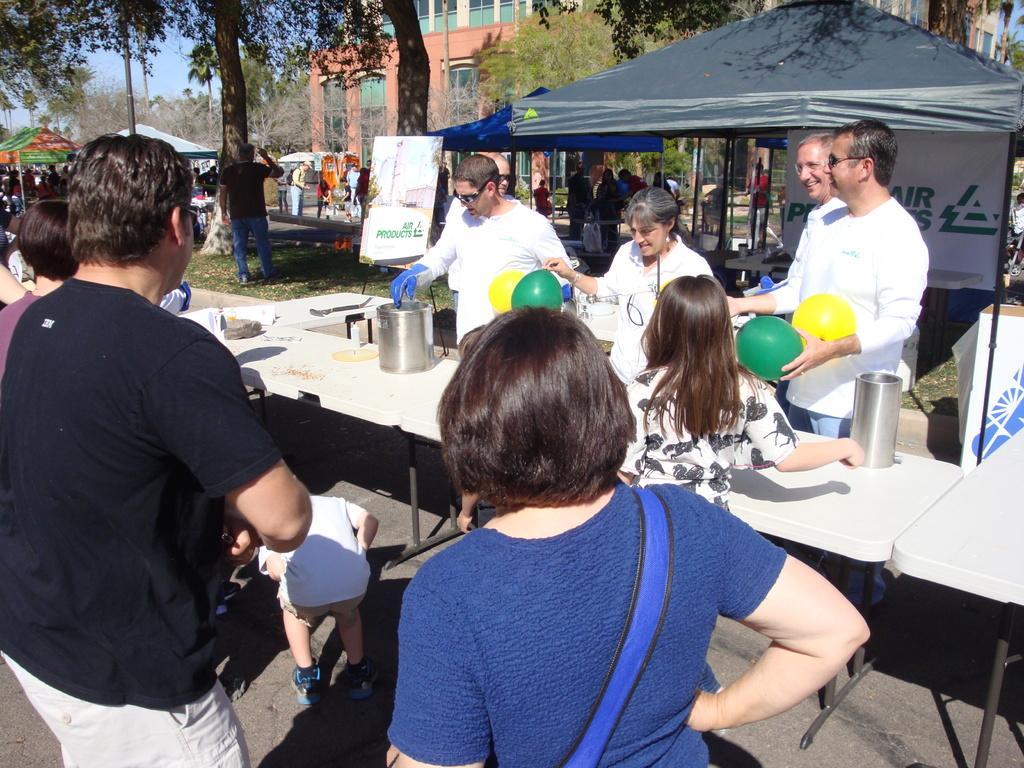Please provide a concise description of this image. This image is of outside. In the center there is a Woman standing and in the left there is a Man and a kid standing. On the right there is a Man and a Woman holding balloons in their hands and standing, behind them there is a black color tint and in the background there are some trees, sky and a Building. 